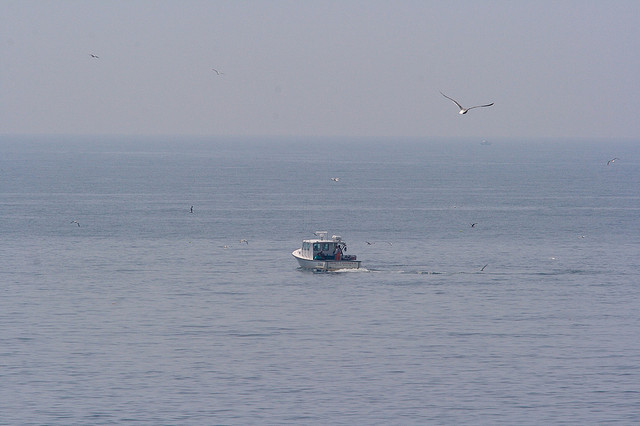<image>How many people are in the boat? It's ambiguous how many people are in the boat. It could be 1, 2 or 3. How many people are in the boat? I don't know how many people are in the boat. It can be either 1, 2 or 3. 